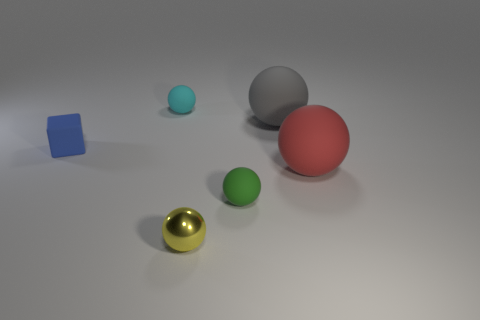Is there a sense of light source and shadow in the image? Yes, the image suggests a single diffuse light source coming from the top, slightly to the right, based on the placement and soft edges of the shadows cast by the objects. Each object creates a soft-edged shadow that is elongated towards the bottom left of the frame, indicating the light source's direction. The shadows are softer and longer for the higher or larger objects and shorter for the lower or smaller objects. 